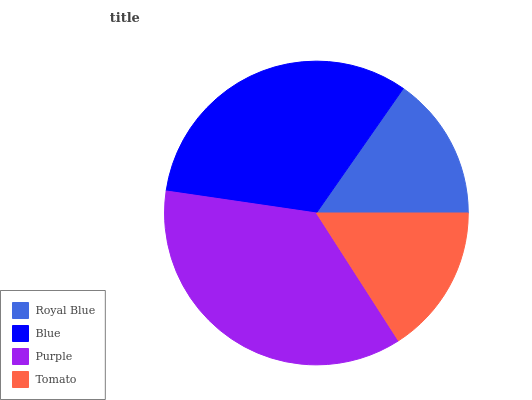Is Royal Blue the minimum?
Answer yes or no. Yes. Is Purple the maximum?
Answer yes or no. Yes. Is Blue the minimum?
Answer yes or no. No. Is Blue the maximum?
Answer yes or no. No. Is Blue greater than Royal Blue?
Answer yes or no. Yes. Is Royal Blue less than Blue?
Answer yes or no. Yes. Is Royal Blue greater than Blue?
Answer yes or no. No. Is Blue less than Royal Blue?
Answer yes or no. No. Is Blue the high median?
Answer yes or no. Yes. Is Tomato the low median?
Answer yes or no. Yes. Is Royal Blue the high median?
Answer yes or no. No. Is Blue the low median?
Answer yes or no. No. 